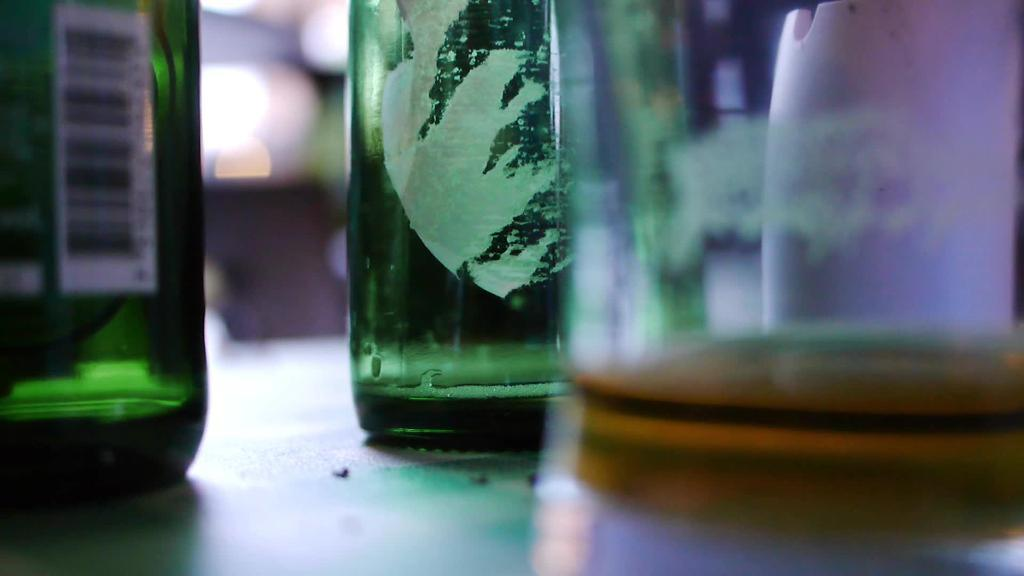What type of containers are visible in the image? There are glass bottles in the image. Where are the glass bottles located? The glass bottles are placed on a surface. Can you describe the background of the image? The background of the image is blurred. What type of rice is being cooked in the image? There is no rice present in the image; it only features glass bottles placed on a surface with a blurred background. 